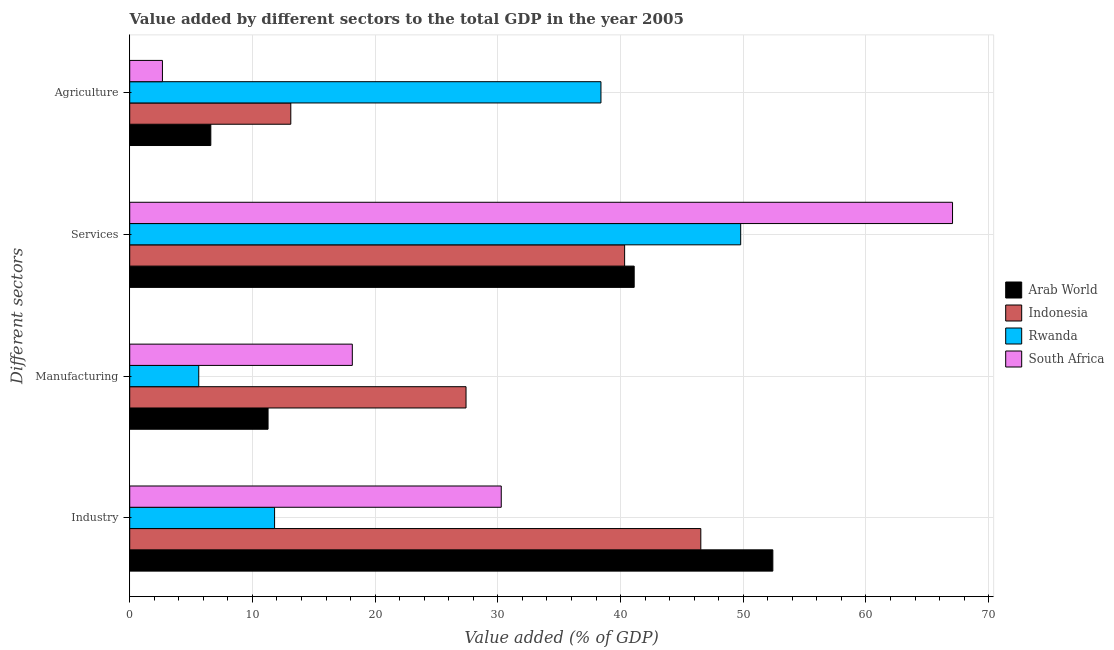How many different coloured bars are there?
Make the answer very short. 4. Are the number of bars per tick equal to the number of legend labels?
Provide a succinct answer. Yes. What is the label of the 4th group of bars from the top?
Your answer should be compact. Industry. What is the value added by industrial sector in Arab World?
Offer a very short reply. 52.41. Across all countries, what is the maximum value added by industrial sector?
Ensure brevity in your answer.  52.41. Across all countries, what is the minimum value added by industrial sector?
Your answer should be compact. 11.81. In which country was the value added by manufacturing sector maximum?
Make the answer very short. Indonesia. In which country was the value added by services sector minimum?
Provide a short and direct response. Indonesia. What is the total value added by agricultural sector in the graph?
Give a very brief answer. 60.8. What is the difference between the value added by industrial sector in South Africa and that in Indonesia?
Ensure brevity in your answer.  -16.26. What is the difference between the value added by manufacturing sector in South Africa and the value added by industrial sector in Arab World?
Your answer should be very brief. -34.27. What is the average value added by industrial sector per country?
Your answer should be very brief. 35.26. What is the difference between the value added by agricultural sector and value added by industrial sector in Indonesia?
Your answer should be compact. -33.41. In how many countries, is the value added by industrial sector greater than 54 %?
Provide a short and direct response. 0. What is the ratio of the value added by industrial sector in South Africa to that in Indonesia?
Make the answer very short. 0.65. Is the value added by industrial sector in Indonesia less than that in Arab World?
Make the answer very short. Yes. What is the difference between the highest and the second highest value added by agricultural sector?
Your response must be concise. 25.28. What is the difference between the highest and the lowest value added by industrial sector?
Provide a succinct answer. 40.61. In how many countries, is the value added by agricultural sector greater than the average value added by agricultural sector taken over all countries?
Provide a short and direct response. 1. Is it the case that in every country, the sum of the value added by manufacturing sector and value added by industrial sector is greater than the sum of value added by agricultural sector and value added by services sector?
Provide a short and direct response. No. What does the 1st bar from the top in Industry represents?
Offer a very short reply. South Africa. What does the 1st bar from the bottom in Manufacturing represents?
Your response must be concise. Arab World. Is it the case that in every country, the sum of the value added by industrial sector and value added by manufacturing sector is greater than the value added by services sector?
Provide a succinct answer. No. Are all the bars in the graph horizontal?
Make the answer very short. Yes. Does the graph contain grids?
Give a very brief answer. Yes. Where does the legend appear in the graph?
Give a very brief answer. Center right. How many legend labels are there?
Keep it short and to the point. 4. How are the legend labels stacked?
Your answer should be very brief. Vertical. What is the title of the graph?
Keep it short and to the point. Value added by different sectors to the total GDP in the year 2005. What is the label or title of the X-axis?
Your response must be concise. Value added (% of GDP). What is the label or title of the Y-axis?
Ensure brevity in your answer.  Different sectors. What is the Value added (% of GDP) in Arab World in Industry?
Your answer should be very brief. 52.41. What is the Value added (% of GDP) in Indonesia in Industry?
Give a very brief answer. 46.54. What is the Value added (% of GDP) in Rwanda in Industry?
Offer a terse response. 11.81. What is the Value added (% of GDP) in South Africa in Industry?
Keep it short and to the point. 30.28. What is the Value added (% of GDP) in Arab World in Manufacturing?
Offer a very short reply. 11.27. What is the Value added (% of GDP) in Indonesia in Manufacturing?
Offer a very short reply. 27.41. What is the Value added (% of GDP) in Rwanda in Manufacturing?
Give a very brief answer. 5.62. What is the Value added (% of GDP) in South Africa in Manufacturing?
Your answer should be very brief. 18.14. What is the Value added (% of GDP) of Arab World in Services?
Ensure brevity in your answer.  41.11. What is the Value added (% of GDP) in Indonesia in Services?
Give a very brief answer. 40.33. What is the Value added (% of GDP) in Rwanda in Services?
Your response must be concise. 49.79. What is the Value added (% of GDP) of South Africa in Services?
Ensure brevity in your answer.  67.06. What is the Value added (% of GDP) in Arab World in Agriculture?
Offer a very short reply. 6.61. What is the Value added (% of GDP) of Indonesia in Agriculture?
Your answer should be compact. 13.13. What is the Value added (% of GDP) in Rwanda in Agriculture?
Keep it short and to the point. 38.4. What is the Value added (% of GDP) of South Africa in Agriculture?
Provide a succinct answer. 2.67. Across all Different sectors, what is the maximum Value added (% of GDP) in Arab World?
Make the answer very short. 52.41. Across all Different sectors, what is the maximum Value added (% of GDP) of Indonesia?
Your response must be concise. 46.54. Across all Different sectors, what is the maximum Value added (% of GDP) in Rwanda?
Ensure brevity in your answer.  49.79. Across all Different sectors, what is the maximum Value added (% of GDP) in South Africa?
Keep it short and to the point. 67.06. Across all Different sectors, what is the minimum Value added (% of GDP) in Arab World?
Your answer should be very brief. 6.61. Across all Different sectors, what is the minimum Value added (% of GDP) in Indonesia?
Your answer should be very brief. 13.13. Across all Different sectors, what is the minimum Value added (% of GDP) of Rwanda?
Provide a short and direct response. 5.62. Across all Different sectors, what is the minimum Value added (% of GDP) in South Africa?
Keep it short and to the point. 2.67. What is the total Value added (% of GDP) of Arab World in the graph?
Your answer should be very brief. 111.41. What is the total Value added (% of GDP) in Indonesia in the graph?
Provide a succinct answer. 127.41. What is the total Value added (% of GDP) of Rwanda in the graph?
Provide a short and direct response. 105.62. What is the total Value added (% of GDP) of South Africa in the graph?
Give a very brief answer. 118.14. What is the difference between the Value added (% of GDP) of Arab World in Industry and that in Manufacturing?
Your response must be concise. 41.14. What is the difference between the Value added (% of GDP) of Indonesia in Industry and that in Manufacturing?
Your answer should be very brief. 19.13. What is the difference between the Value added (% of GDP) in Rwanda in Industry and that in Manufacturing?
Your response must be concise. 6.18. What is the difference between the Value added (% of GDP) in South Africa in Industry and that in Manufacturing?
Offer a very short reply. 12.14. What is the difference between the Value added (% of GDP) of Arab World in Industry and that in Services?
Make the answer very short. 11.3. What is the difference between the Value added (% of GDP) of Indonesia in Industry and that in Services?
Provide a short and direct response. 6.21. What is the difference between the Value added (% of GDP) in Rwanda in Industry and that in Services?
Your answer should be very brief. -37.99. What is the difference between the Value added (% of GDP) of South Africa in Industry and that in Services?
Give a very brief answer. -36.78. What is the difference between the Value added (% of GDP) of Arab World in Industry and that in Agriculture?
Provide a short and direct response. 45.8. What is the difference between the Value added (% of GDP) of Indonesia in Industry and that in Agriculture?
Your answer should be very brief. 33.41. What is the difference between the Value added (% of GDP) of Rwanda in Industry and that in Agriculture?
Offer a terse response. -26.6. What is the difference between the Value added (% of GDP) of South Africa in Industry and that in Agriculture?
Offer a very short reply. 27.61. What is the difference between the Value added (% of GDP) of Arab World in Manufacturing and that in Services?
Give a very brief answer. -29.84. What is the difference between the Value added (% of GDP) of Indonesia in Manufacturing and that in Services?
Make the answer very short. -12.92. What is the difference between the Value added (% of GDP) in Rwanda in Manufacturing and that in Services?
Ensure brevity in your answer.  -44.17. What is the difference between the Value added (% of GDP) of South Africa in Manufacturing and that in Services?
Provide a short and direct response. -48.92. What is the difference between the Value added (% of GDP) of Arab World in Manufacturing and that in Agriculture?
Offer a very short reply. 4.66. What is the difference between the Value added (% of GDP) in Indonesia in Manufacturing and that in Agriculture?
Your response must be concise. 14.28. What is the difference between the Value added (% of GDP) in Rwanda in Manufacturing and that in Agriculture?
Offer a terse response. -32.78. What is the difference between the Value added (% of GDP) in South Africa in Manufacturing and that in Agriculture?
Your answer should be compact. 15.47. What is the difference between the Value added (% of GDP) in Arab World in Services and that in Agriculture?
Keep it short and to the point. 34.5. What is the difference between the Value added (% of GDP) in Indonesia in Services and that in Agriculture?
Make the answer very short. 27.21. What is the difference between the Value added (% of GDP) of Rwanda in Services and that in Agriculture?
Give a very brief answer. 11.39. What is the difference between the Value added (% of GDP) of South Africa in Services and that in Agriculture?
Your answer should be compact. 64.39. What is the difference between the Value added (% of GDP) in Arab World in Industry and the Value added (% of GDP) in Indonesia in Manufacturing?
Keep it short and to the point. 25. What is the difference between the Value added (% of GDP) of Arab World in Industry and the Value added (% of GDP) of Rwanda in Manufacturing?
Give a very brief answer. 46.79. What is the difference between the Value added (% of GDP) of Arab World in Industry and the Value added (% of GDP) of South Africa in Manufacturing?
Offer a terse response. 34.27. What is the difference between the Value added (% of GDP) of Indonesia in Industry and the Value added (% of GDP) of Rwanda in Manufacturing?
Offer a very short reply. 40.92. What is the difference between the Value added (% of GDP) in Indonesia in Industry and the Value added (% of GDP) in South Africa in Manufacturing?
Offer a very short reply. 28.4. What is the difference between the Value added (% of GDP) in Rwanda in Industry and the Value added (% of GDP) in South Africa in Manufacturing?
Ensure brevity in your answer.  -6.33. What is the difference between the Value added (% of GDP) of Arab World in Industry and the Value added (% of GDP) of Indonesia in Services?
Your response must be concise. 12.08. What is the difference between the Value added (% of GDP) of Arab World in Industry and the Value added (% of GDP) of Rwanda in Services?
Your response must be concise. 2.62. What is the difference between the Value added (% of GDP) of Arab World in Industry and the Value added (% of GDP) of South Africa in Services?
Give a very brief answer. -14.64. What is the difference between the Value added (% of GDP) of Indonesia in Industry and the Value added (% of GDP) of Rwanda in Services?
Make the answer very short. -3.25. What is the difference between the Value added (% of GDP) of Indonesia in Industry and the Value added (% of GDP) of South Africa in Services?
Provide a short and direct response. -20.52. What is the difference between the Value added (% of GDP) in Rwanda in Industry and the Value added (% of GDP) in South Africa in Services?
Your answer should be compact. -55.25. What is the difference between the Value added (% of GDP) of Arab World in Industry and the Value added (% of GDP) of Indonesia in Agriculture?
Your answer should be very brief. 39.28. What is the difference between the Value added (% of GDP) of Arab World in Industry and the Value added (% of GDP) of Rwanda in Agriculture?
Make the answer very short. 14.01. What is the difference between the Value added (% of GDP) in Arab World in Industry and the Value added (% of GDP) in South Africa in Agriculture?
Offer a terse response. 49.75. What is the difference between the Value added (% of GDP) of Indonesia in Industry and the Value added (% of GDP) of Rwanda in Agriculture?
Make the answer very short. 8.14. What is the difference between the Value added (% of GDP) in Indonesia in Industry and the Value added (% of GDP) in South Africa in Agriculture?
Provide a succinct answer. 43.87. What is the difference between the Value added (% of GDP) of Rwanda in Industry and the Value added (% of GDP) of South Africa in Agriculture?
Ensure brevity in your answer.  9.14. What is the difference between the Value added (% of GDP) of Arab World in Manufacturing and the Value added (% of GDP) of Indonesia in Services?
Offer a very short reply. -29.06. What is the difference between the Value added (% of GDP) of Arab World in Manufacturing and the Value added (% of GDP) of Rwanda in Services?
Offer a very short reply. -38.52. What is the difference between the Value added (% of GDP) of Arab World in Manufacturing and the Value added (% of GDP) of South Africa in Services?
Your answer should be very brief. -55.78. What is the difference between the Value added (% of GDP) of Indonesia in Manufacturing and the Value added (% of GDP) of Rwanda in Services?
Provide a short and direct response. -22.38. What is the difference between the Value added (% of GDP) in Indonesia in Manufacturing and the Value added (% of GDP) in South Africa in Services?
Offer a very short reply. -39.65. What is the difference between the Value added (% of GDP) of Rwanda in Manufacturing and the Value added (% of GDP) of South Africa in Services?
Your answer should be compact. -61.43. What is the difference between the Value added (% of GDP) in Arab World in Manufacturing and the Value added (% of GDP) in Indonesia in Agriculture?
Give a very brief answer. -1.85. What is the difference between the Value added (% of GDP) in Arab World in Manufacturing and the Value added (% of GDP) in Rwanda in Agriculture?
Keep it short and to the point. -27.13. What is the difference between the Value added (% of GDP) of Arab World in Manufacturing and the Value added (% of GDP) of South Africa in Agriculture?
Provide a short and direct response. 8.61. What is the difference between the Value added (% of GDP) in Indonesia in Manufacturing and the Value added (% of GDP) in Rwanda in Agriculture?
Your response must be concise. -11. What is the difference between the Value added (% of GDP) of Indonesia in Manufacturing and the Value added (% of GDP) of South Africa in Agriculture?
Ensure brevity in your answer.  24.74. What is the difference between the Value added (% of GDP) in Rwanda in Manufacturing and the Value added (% of GDP) in South Africa in Agriculture?
Ensure brevity in your answer.  2.96. What is the difference between the Value added (% of GDP) of Arab World in Services and the Value added (% of GDP) of Indonesia in Agriculture?
Keep it short and to the point. 27.99. What is the difference between the Value added (% of GDP) of Arab World in Services and the Value added (% of GDP) of Rwanda in Agriculture?
Make the answer very short. 2.71. What is the difference between the Value added (% of GDP) in Arab World in Services and the Value added (% of GDP) in South Africa in Agriculture?
Offer a very short reply. 38.45. What is the difference between the Value added (% of GDP) in Indonesia in Services and the Value added (% of GDP) in Rwanda in Agriculture?
Provide a succinct answer. 1.93. What is the difference between the Value added (% of GDP) in Indonesia in Services and the Value added (% of GDP) in South Africa in Agriculture?
Provide a succinct answer. 37.67. What is the difference between the Value added (% of GDP) of Rwanda in Services and the Value added (% of GDP) of South Africa in Agriculture?
Keep it short and to the point. 47.13. What is the average Value added (% of GDP) in Arab World per Different sectors?
Your answer should be compact. 27.85. What is the average Value added (% of GDP) of Indonesia per Different sectors?
Offer a terse response. 31.85. What is the average Value added (% of GDP) in Rwanda per Different sectors?
Offer a terse response. 26.41. What is the average Value added (% of GDP) in South Africa per Different sectors?
Offer a terse response. 29.53. What is the difference between the Value added (% of GDP) of Arab World and Value added (% of GDP) of Indonesia in Industry?
Provide a succinct answer. 5.87. What is the difference between the Value added (% of GDP) in Arab World and Value added (% of GDP) in Rwanda in Industry?
Your answer should be compact. 40.61. What is the difference between the Value added (% of GDP) in Arab World and Value added (% of GDP) in South Africa in Industry?
Provide a succinct answer. 22.13. What is the difference between the Value added (% of GDP) of Indonesia and Value added (% of GDP) of Rwanda in Industry?
Provide a succinct answer. 34.74. What is the difference between the Value added (% of GDP) in Indonesia and Value added (% of GDP) in South Africa in Industry?
Your answer should be compact. 16.26. What is the difference between the Value added (% of GDP) of Rwanda and Value added (% of GDP) of South Africa in Industry?
Keep it short and to the point. -18.47. What is the difference between the Value added (% of GDP) in Arab World and Value added (% of GDP) in Indonesia in Manufacturing?
Give a very brief answer. -16.13. What is the difference between the Value added (% of GDP) of Arab World and Value added (% of GDP) of Rwanda in Manufacturing?
Offer a terse response. 5.65. What is the difference between the Value added (% of GDP) of Arab World and Value added (% of GDP) of South Africa in Manufacturing?
Keep it short and to the point. -6.87. What is the difference between the Value added (% of GDP) of Indonesia and Value added (% of GDP) of Rwanda in Manufacturing?
Make the answer very short. 21.78. What is the difference between the Value added (% of GDP) in Indonesia and Value added (% of GDP) in South Africa in Manufacturing?
Your answer should be very brief. 9.27. What is the difference between the Value added (% of GDP) of Rwanda and Value added (% of GDP) of South Africa in Manufacturing?
Offer a terse response. -12.51. What is the difference between the Value added (% of GDP) in Arab World and Value added (% of GDP) in Indonesia in Services?
Offer a very short reply. 0.78. What is the difference between the Value added (% of GDP) in Arab World and Value added (% of GDP) in Rwanda in Services?
Your response must be concise. -8.68. What is the difference between the Value added (% of GDP) in Arab World and Value added (% of GDP) in South Africa in Services?
Provide a succinct answer. -25.94. What is the difference between the Value added (% of GDP) in Indonesia and Value added (% of GDP) in Rwanda in Services?
Make the answer very short. -9.46. What is the difference between the Value added (% of GDP) in Indonesia and Value added (% of GDP) in South Africa in Services?
Your response must be concise. -26.72. What is the difference between the Value added (% of GDP) in Rwanda and Value added (% of GDP) in South Africa in Services?
Offer a terse response. -17.26. What is the difference between the Value added (% of GDP) of Arab World and Value added (% of GDP) of Indonesia in Agriculture?
Provide a succinct answer. -6.52. What is the difference between the Value added (% of GDP) of Arab World and Value added (% of GDP) of Rwanda in Agriculture?
Keep it short and to the point. -31.79. What is the difference between the Value added (% of GDP) of Arab World and Value added (% of GDP) of South Africa in Agriculture?
Your answer should be very brief. 3.94. What is the difference between the Value added (% of GDP) of Indonesia and Value added (% of GDP) of Rwanda in Agriculture?
Offer a terse response. -25.28. What is the difference between the Value added (% of GDP) in Indonesia and Value added (% of GDP) in South Africa in Agriculture?
Offer a terse response. 10.46. What is the difference between the Value added (% of GDP) of Rwanda and Value added (% of GDP) of South Africa in Agriculture?
Offer a very short reply. 35.74. What is the ratio of the Value added (% of GDP) of Arab World in Industry to that in Manufacturing?
Offer a terse response. 4.65. What is the ratio of the Value added (% of GDP) in Indonesia in Industry to that in Manufacturing?
Provide a short and direct response. 1.7. What is the ratio of the Value added (% of GDP) in Rwanda in Industry to that in Manufacturing?
Offer a terse response. 2.1. What is the ratio of the Value added (% of GDP) in South Africa in Industry to that in Manufacturing?
Make the answer very short. 1.67. What is the ratio of the Value added (% of GDP) of Arab World in Industry to that in Services?
Make the answer very short. 1.27. What is the ratio of the Value added (% of GDP) in Indonesia in Industry to that in Services?
Ensure brevity in your answer.  1.15. What is the ratio of the Value added (% of GDP) of Rwanda in Industry to that in Services?
Your response must be concise. 0.24. What is the ratio of the Value added (% of GDP) in South Africa in Industry to that in Services?
Give a very brief answer. 0.45. What is the ratio of the Value added (% of GDP) in Arab World in Industry to that in Agriculture?
Offer a very short reply. 7.93. What is the ratio of the Value added (% of GDP) in Indonesia in Industry to that in Agriculture?
Ensure brevity in your answer.  3.55. What is the ratio of the Value added (% of GDP) of Rwanda in Industry to that in Agriculture?
Provide a succinct answer. 0.31. What is the ratio of the Value added (% of GDP) in South Africa in Industry to that in Agriculture?
Provide a short and direct response. 11.36. What is the ratio of the Value added (% of GDP) in Arab World in Manufacturing to that in Services?
Your response must be concise. 0.27. What is the ratio of the Value added (% of GDP) in Indonesia in Manufacturing to that in Services?
Your response must be concise. 0.68. What is the ratio of the Value added (% of GDP) in Rwanda in Manufacturing to that in Services?
Your answer should be compact. 0.11. What is the ratio of the Value added (% of GDP) in South Africa in Manufacturing to that in Services?
Offer a very short reply. 0.27. What is the ratio of the Value added (% of GDP) in Arab World in Manufacturing to that in Agriculture?
Your answer should be very brief. 1.71. What is the ratio of the Value added (% of GDP) in Indonesia in Manufacturing to that in Agriculture?
Offer a terse response. 2.09. What is the ratio of the Value added (% of GDP) of Rwanda in Manufacturing to that in Agriculture?
Ensure brevity in your answer.  0.15. What is the ratio of the Value added (% of GDP) of South Africa in Manufacturing to that in Agriculture?
Provide a short and direct response. 6.8. What is the ratio of the Value added (% of GDP) in Arab World in Services to that in Agriculture?
Keep it short and to the point. 6.22. What is the ratio of the Value added (% of GDP) of Indonesia in Services to that in Agriculture?
Provide a short and direct response. 3.07. What is the ratio of the Value added (% of GDP) in Rwanda in Services to that in Agriculture?
Make the answer very short. 1.3. What is the ratio of the Value added (% of GDP) in South Africa in Services to that in Agriculture?
Make the answer very short. 25.15. What is the difference between the highest and the second highest Value added (% of GDP) of Arab World?
Give a very brief answer. 11.3. What is the difference between the highest and the second highest Value added (% of GDP) of Indonesia?
Provide a short and direct response. 6.21. What is the difference between the highest and the second highest Value added (% of GDP) in Rwanda?
Keep it short and to the point. 11.39. What is the difference between the highest and the second highest Value added (% of GDP) of South Africa?
Your answer should be compact. 36.78. What is the difference between the highest and the lowest Value added (% of GDP) in Arab World?
Your response must be concise. 45.8. What is the difference between the highest and the lowest Value added (% of GDP) of Indonesia?
Ensure brevity in your answer.  33.41. What is the difference between the highest and the lowest Value added (% of GDP) in Rwanda?
Give a very brief answer. 44.17. What is the difference between the highest and the lowest Value added (% of GDP) of South Africa?
Keep it short and to the point. 64.39. 